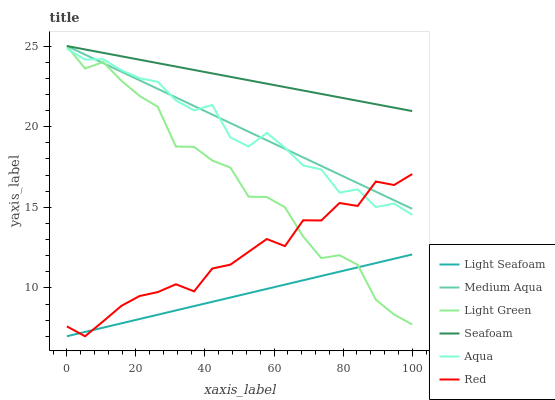Does Medium Aqua have the minimum area under the curve?
Answer yes or no. No. Does Medium Aqua have the maximum area under the curve?
Answer yes or no. No. Is Seafoam the smoothest?
Answer yes or no. No. Is Seafoam the roughest?
Answer yes or no. No. Does Medium Aqua have the lowest value?
Answer yes or no. No. Does Light Seafoam have the highest value?
Answer yes or no. No. Is Red less than Seafoam?
Answer yes or no. Yes. Is Seafoam greater than Light Seafoam?
Answer yes or no. Yes. Does Red intersect Seafoam?
Answer yes or no. No. 